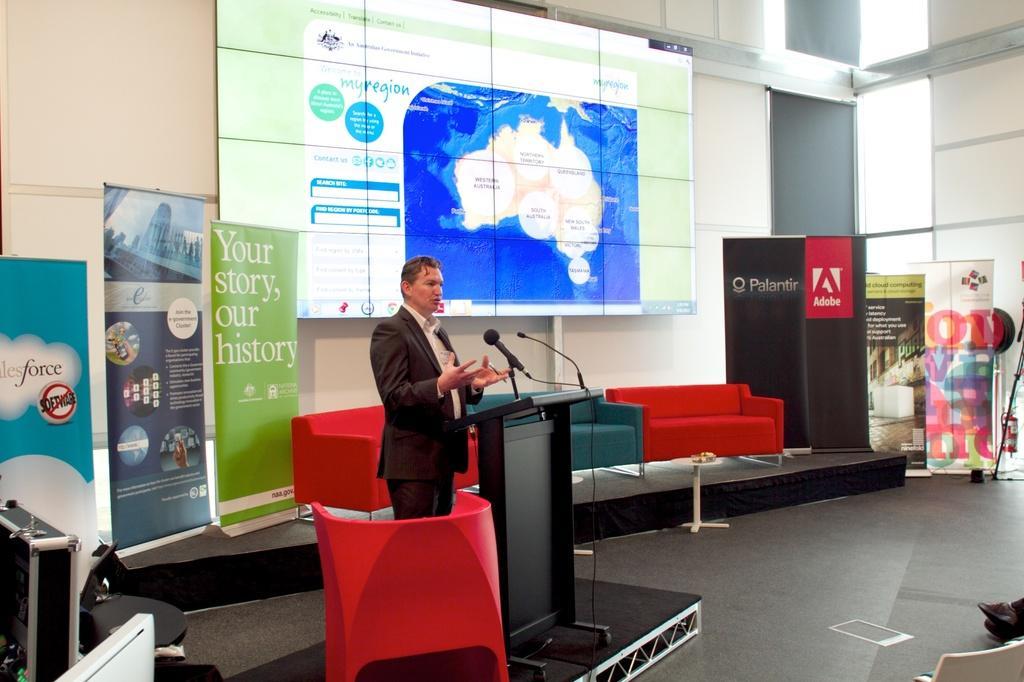Could you give a brief overview of what you see in this image? In this image I can see a person, couches, podium, mics, chair, banners, screen, windows, person legs, table, fire extinguisher and objects. Something is written on the banners and screen. In-front of that person there is a podium and mics. 